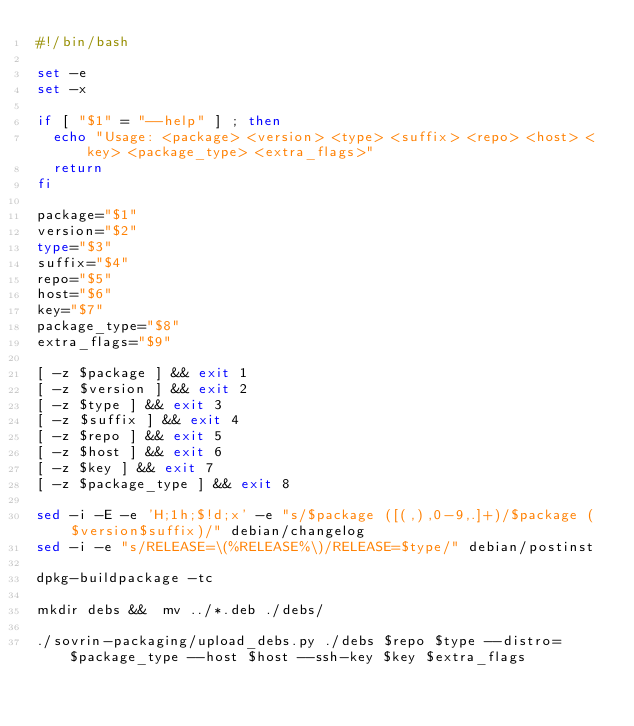<code> <loc_0><loc_0><loc_500><loc_500><_Bash_>#!/bin/bash

set -e
set -x

if [ "$1" = "--help" ] ; then
  echo "Usage: <package> <version> <type> <suffix> <repo> <host> <key> <package_type> <extra_flags>"
  return
fi

package="$1"
version="$2"
type="$3"
suffix="$4"
repo="$5"
host="$6"
key="$7"
package_type="$8"
extra_flags="$9"

[ -z $package ] && exit 1
[ -z $version ] && exit 2
[ -z $type ] && exit 3
[ -z $suffix ] && exit 4
[ -z $repo ] && exit 5
[ -z $host ] && exit 6
[ -z $key ] && exit 7
[ -z $package_type ] && exit 8

sed -i -E -e 'H;1h;$!d;x' -e "s/$package ([(,),0-9,.]+)/$package ($version$suffix)/" debian/changelog
sed -i -e "s/RELEASE=\(%RELEASE%\)/RELEASE=$type/" debian/postinst

dpkg-buildpackage -tc

mkdir debs &&  mv ../*.deb ./debs/

./sovrin-packaging/upload_debs.py ./debs $repo $type --distro=$package_type --host $host --ssh-key $key $extra_flags
</code> 